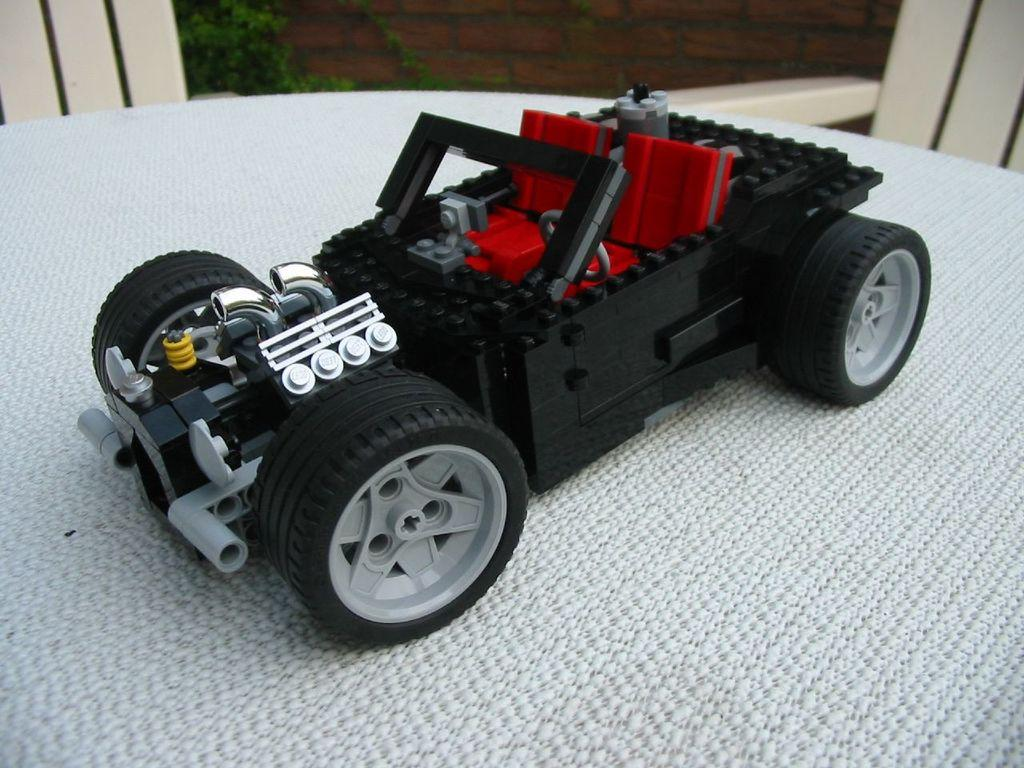What object is placed on the table in the image? There is a toy car placed on a table in the image. What can be seen in the background of the image? There are two chairs and a tree in the background of the image. What type of glove is being used to play with the toy car in the image? There is no glove present in the image, and the toy car is not being played with. 